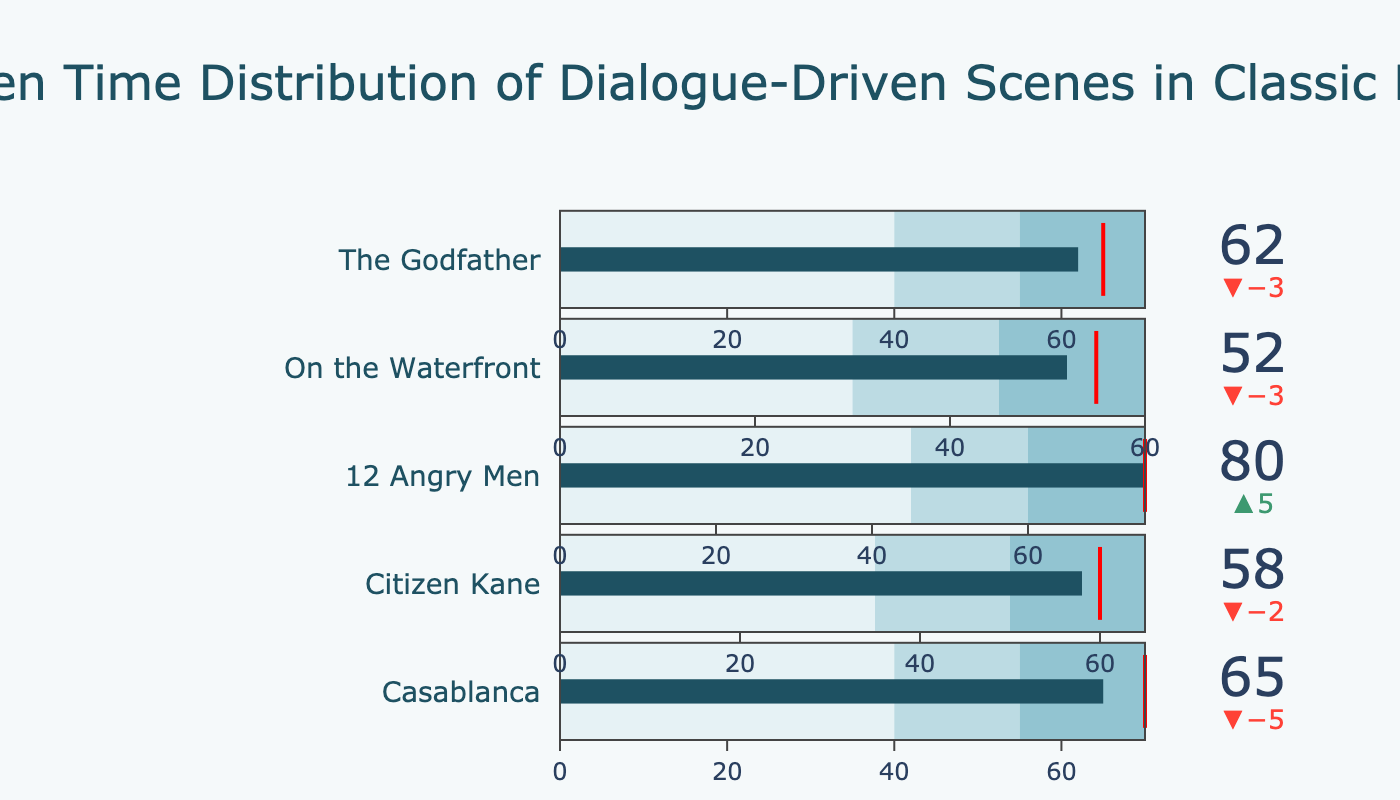What is the title of the plot? The title is usually located at the top of the plot in a larger and bold font. Here, it is written as "Screen Time Distribution of Dialogue-Driven Scenes in Classic Films."
Answer: Screen Time Distribution of Dialogue-Driven Scenes in Classic Films How many films are included in the plot? Each film appears as a separate gauge indicator within the plot. By counting all the distinct indicators, we find five films are represented.
Answer: 5 Which film has the highest actual screen time for dialogue-driven scenes? By examining each film's actual value, the highest one is noted. "12 Angry Men" has the highest value of 80 minutes.
Answer: 12 Angry Men How does the actual screen time of "The Godfather" compare to its target? To answer this, compare the "Actual" value of "The Godfather" with its "Target" value. "The Godfather" has an actual screen time of 62 minutes, whereas the target is 65 minutes. It falls short by 3 minutes.
Answer: 3 minutes short Which films exceeded their target value for dialogue-driven scene screen time? Compare the "Actual" and "Target" values for each film. "12 Angry Men," with an actual of 80 and a target of 75, is the only film exceeding its target.
Answer: 12 Angry Men What is the average target screen time across all the films? Sum of all target values (70 + 60 + 75 + 55 + 65) divided by the number of films (5) gives the average. Thus, (70 + 60 + 75 + 55 + 65) = 325. Divide by 5 equals 65 minutes.
Answer: 65 minutes Which film has the closest actual screen time to its target? Calculate the difference between the actual and target for each film. "Citizen Kane" has an actual of 58 and a target of 60, giving a difference of 2 minutes, which is the smallest difference.
Answer: Citizen Kane For "Casablanca," what color range does its actual screen time fall into? The actual value for "Casablanca" is 65. "Range1" is 0-40, "Range2" is 40-55, and "Range3" is 55-70. Since 65 falls within 55-70, it is in the darkest blue range.
Answer: Darkest blue range How far below its target is "On the Waterfront"? Subtract the actual value from the target value for "On the Waterfront." The target is 55 and the actual is 52. So, 55 - 52 = 3 minutes.
Answer: 3 minutes What is the range of screen time values displayed for "Citizen Kane"? "Citizen Kane" has ranges labeled as Range1 (0-35), Range2 (35-50), and Range3 (50-65) on its gauge. The gauge displays values from 0 to 65 minutes.
Answer: 0 to 65 minutes 